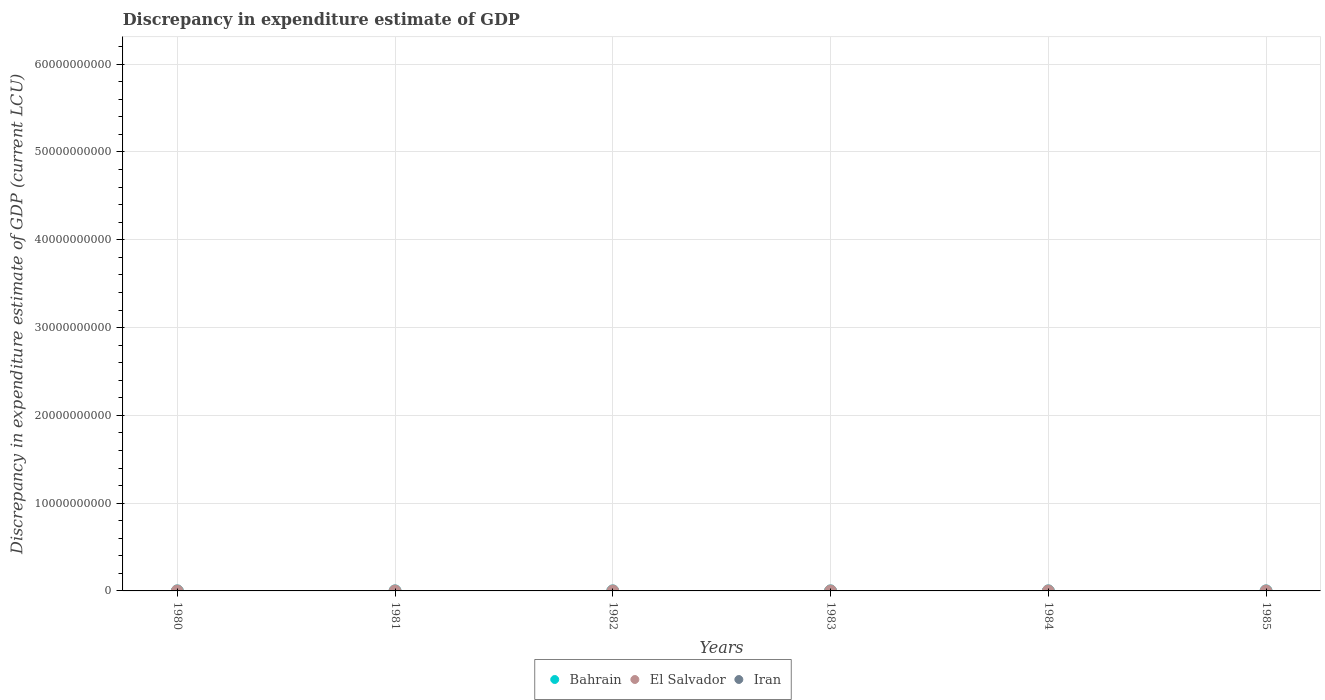Is the number of dotlines equal to the number of legend labels?
Your response must be concise. No. Across all years, what is the maximum discrepancy in expenditure estimate of GDP in El Salvador?
Your response must be concise. 200. Across all years, what is the minimum discrepancy in expenditure estimate of GDP in Iran?
Give a very brief answer. 0. In which year was the discrepancy in expenditure estimate of GDP in Bahrain maximum?
Give a very brief answer. 1983. What is the total discrepancy in expenditure estimate of GDP in El Salvador in the graph?
Make the answer very short. 600. What is the difference between the discrepancy in expenditure estimate of GDP in El Salvador in 1981 and that in 1984?
Offer a terse response. 200. What is the difference between the discrepancy in expenditure estimate of GDP in El Salvador in 1980 and the discrepancy in expenditure estimate of GDP in Bahrain in 1982?
Give a very brief answer. -100. What is the average discrepancy in expenditure estimate of GDP in Iran per year?
Give a very brief answer. 0. In how many years, is the discrepancy in expenditure estimate of GDP in Iran greater than 36000000000 LCU?
Provide a short and direct response. 0. Is the discrepancy in expenditure estimate of GDP in El Salvador in 1981 less than that in 1984?
Your answer should be compact. No. What is the difference between the highest and the second highest discrepancy in expenditure estimate of GDP in El Salvador?
Provide a short and direct response. 2.599999788799323e-7. What is the difference between the highest and the lowest discrepancy in expenditure estimate of GDP in El Salvador?
Provide a succinct answer. 200. In how many years, is the discrepancy in expenditure estimate of GDP in Iran greater than the average discrepancy in expenditure estimate of GDP in Iran taken over all years?
Provide a short and direct response. 0. Is the sum of the discrepancy in expenditure estimate of GDP in Bahrain in 1982 and 1983 greater than the maximum discrepancy in expenditure estimate of GDP in Iran across all years?
Your response must be concise. Yes. Does the discrepancy in expenditure estimate of GDP in El Salvador monotonically increase over the years?
Provide a short and direct response. No. Is the discrepancy in expenditure estimate of GDP in Iran strictly less than the discrepancy in expenditure estimate of GDP in El Salvador over the years?
Your answer should be very brief. Yes. How many years are there in the graph?
Ensure brevity in your answer.  6. What is the difference between two consecutive major ticks on the Y-axis?
Offer a terse response. 1.00e+1. How many legend labels are there?
Offer a terse response. 3. What is the title of the graph?
Offer a terse response. Discrepancy in expenditure estimate of GDP. What is the label or title of the Y-axis?
Your answer should be very brief. Discrepancy in expenditure estimate of GDP (current LCU). What is the Discrepancy in expenditure estimate of GDP (current LCU) in Bahrain in 1980?
Ensure brevity in your answer.  0. What is the Discrepancy in expenditure estimate of GDP (current LCU) of Iran in 1980?
Your response must be concise. 0. What is the Discrepancy in expenditure estimate of GDP (current LCU) in Bahrain in 1981?
Offer a terse response. 0. What is the Discrepancy in expenditure estimate of GDP (current LCU) of El Salvador in 1981?
Make the answer very short. 200. What is the Discrepancy in expenditure estimate of GDP (current LCU) of Bahrain in 1982?
Ensure brevity in your answer.  100. What is the Discrepancy in expenditure estimate of GDP (current LCU) of El Salvador in 1982?
Make the answer very short. 200. What is the Discrepancy in expenditure estimate of GDP (current LCU) in Iran in 1982?
Offer a very short reply. 0. What is the Discrepancy in expenditure estimate of GDP (current LCU) in Bahrain in 1983?
Provide a succinct answer. 300. What is the Discrepancy in expenditure estimate of GDP (current LCU) in El Salvador in 1984?
Provide a short and direct response. 6e-8. What is the Discrepancy in expenditure estimate of GDP (current LCU) in Bahrain in 1985?
Ensure brevity in your answer.  0. What is the Discrepancy in expenditure estimate of GDP (current LCU) in El Salvador in 1985?
Provide a succinct answer. 200. What is the Discrepancy in expenditure estimate of GDP (current LCU) in Iran in 1985?
Offer a very short reply. 0. Across all years, what is the maximum Discrepancy in expenditure estimate of GDP (current LCU) of Bahrain?
Give a very brief answer. 300. Across all years, what is the maximum Discrepancy in expenditure estimate of GDP (current LCU) in El Salvador?
Give a very brief answer. 200. Across all years, what is the minimum Discrepancy in expenditure estimate of GDP (current LCU) of Bahrain?
Offer a terse response. 0. Across all years, what is the minimum Discrepancy in expenditure estimate of GDP (current LCU) in El Salvador?
Provide a succinct answer. 0. What is the total Discrepancy in expenditure estimate of GDP (current LCU) of El Salvador in the graph?
Your answer should be compact. 600. What is the difference between the Discrepancy in expenditure estimate of GDP (current LCU) of El Salvador in 1981 and that in 1985?
Make the answer very short. 0. What is the difference between the Discrepancy in expenditure estimate of GDP (current LCU) of Bahrain in 1982 and that in 1983?
Your response must be concise. -200. What is the difference between the Discrepancy in expenditure estimate of GDP (current LCU) in El Salvador in 1982 and that in 1984?
Provide a short and direct response. 200. What is the difference between the Discrepancy in expenditure estimate of GDP (current LCU) in El Salvador in 1982 and that in 1985?
Offer a very short reply. -0. What is the difference between the Discrepancy in expenditure estimate of GDP (current LCU) in El Salvador in 1984 and that in 1985?
Make the answer very short. -200. What is the difference between the Discrepancy in expenditure estimate of GDP (current LCU) of Bahrain in 1982 and the Discrepancy in expenditure estimate of GDP (current LCU) of El Salvador in 1985?
Your answer should be compact. -100. What is the difference between the Discrepancy in expenditure estimate of GDP (current LCU) in Bahrain in 1983 and the Discrepancy in expenditure estimate of GDP (current LCU) in El Salvador in 1984?
Keep it short and to the point. 300. What is the average Discrepancy in expenditure estimate of GDP (current LCU) in Bahrain per year?
Make the answer very short. 66.67. What is the average Discrepancy in expenditure estimate of GDP (current LCU) of El Salvador per year?
Offer a terse response. 100. In the year 1982, what is the difference between the Discrepancy in expenditure estimate of GDP (current LCU) of Bahrain and Discrepancy in expenditure estimate of GDP (current LCU) of El Salvador?
Your answer should be compact. -100. What is the ratio of the Discrepancy in expenditure estimate of GDP (current LCU) of El Salvador in 1981 to that in 1984?
Your answer should be very brief. 3.33e+09. What is the ratio of the Discrepancy in expenditure estimate of GDP (current LCU) in Bahrain in 1982 to that in 1983?
Ensure brevity in your answer.  0.33. What is the ratio of the Discrepancy in expenditure estimate of GDP (current LCU) in El Salvador in 1982 to that in 1984?
Give a very brief answer. 3.33e+09. What is the ratio of the Discrepancy in expenditure estimate of GDP (current LCU) in El Salvador in 1984 to that in 1985?
Give a very brief answer. 0. What is the difference between the highest and the lowest Discrepancy in expenditure estimate of GDP (current LCU) in Bahrain?
Give a very brief answer. 300. 